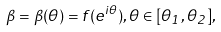Convert formula to latex. <formula><loc_0><loc_0><loc_500><loc_500>\beta = \beta ( \theta ) = f ( e ^ { i \theta } ) , \theta \in [ \theta _ { 1 } , \theta _ { 2 } ] ,</formula> 